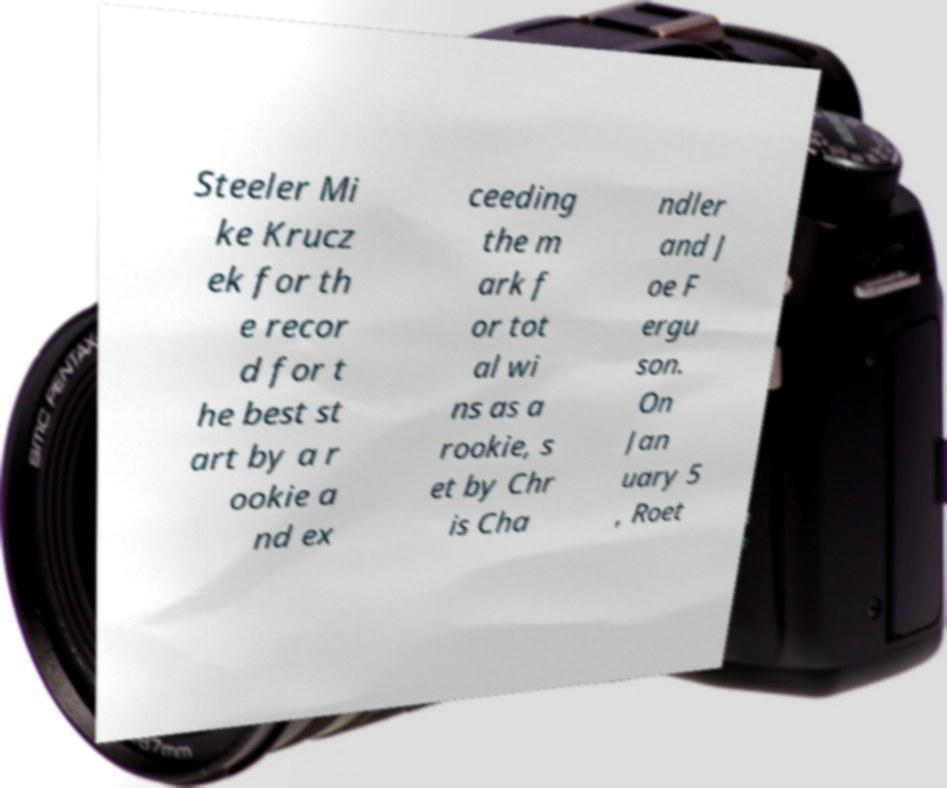Can you read and provide the text displayed in the image?This photo seems to have some interesting text. Can you extract and type it out for me? Steeler Mi ke Krucz ek for th e recor d for t he best st art by a r ookie a nd ex ceeding the m ark f or tot al wi ns as a rookie, s et by Chr is Cha ndler and J oe F ergu son. On Jan uary 5 , Roet 